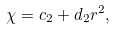Convert formula to latex. <formula><loc_0><loc_0><loc_500><loc_500>\chi = c _ { 2 } + d _ { 2 } r ^ { 2 } ,</formula> 